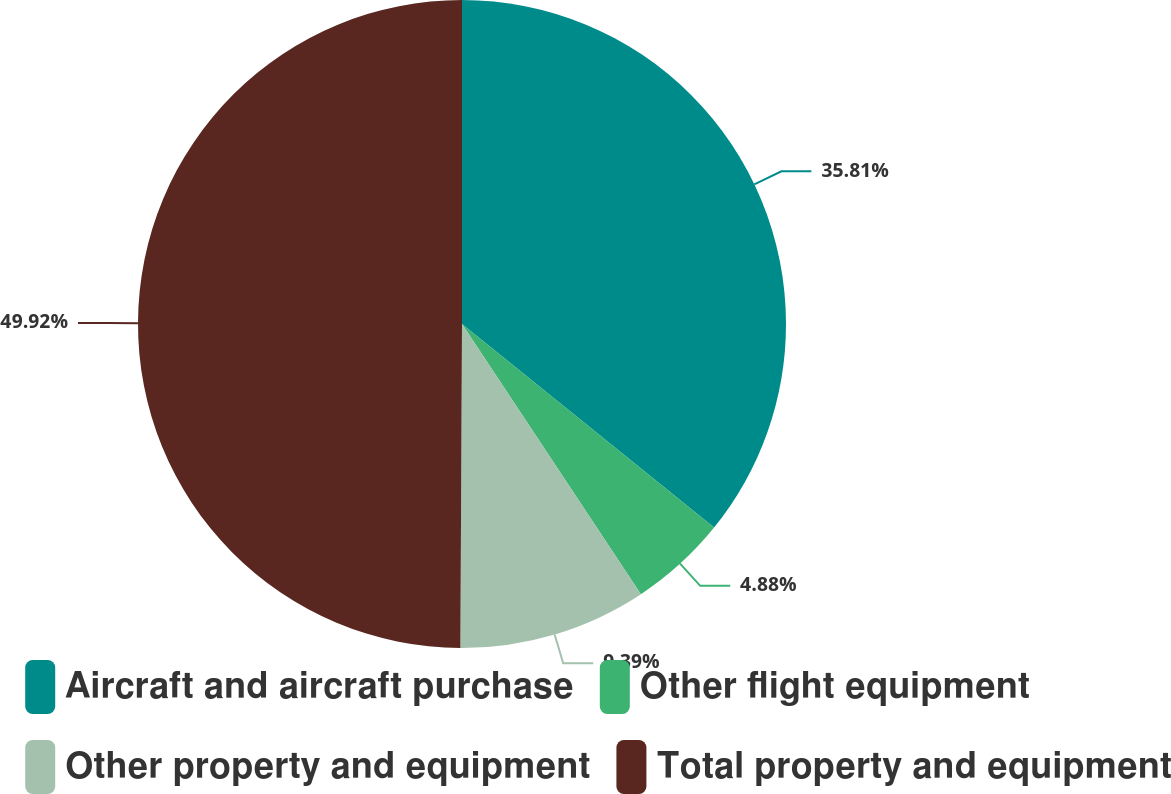<chart> <loc_0><loc_0><loc_500><loc_500><pie_chart><fcel>Aircraft and aircraft purchase<fcel>Other flight equipment<fcel>Other property and equipment<fcel>Total property and equipment<nl><fcel>35.81%<fcel>4.88%<fcel>9.39%<fcel>49.92%<nl></chart> 